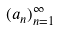Convert formula to latex. <formula><loc_0><loc_0><loc_500><loc_500>( a _ { n } ) _ { n = 1 } ^ { \infty }</formula> 